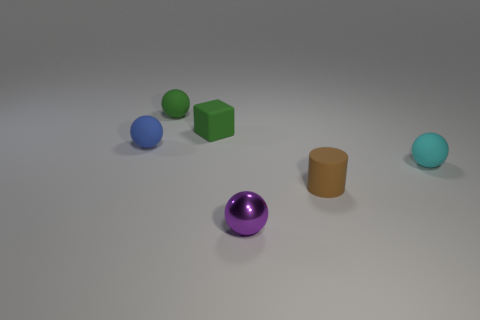Add 3 gray rubber balls. How many objects exist? 9 Subtract all cylinders. How many objects are left? 5 Subtract all small purple rubber cylinders. Subtract all matte objects. How many objects are left? 1 Add 2 small blue rubber objects. How many small blue rubber objects are left? 3 Add 6 tiny brown matte cylinders. How many tiny brown matte cylinders exist? 7 Subtract 1 green spheres. How many objects are left? 5 